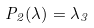<formula> <loc_0><loc_0><loc_500><loc_500>P _ { 2 } ( \lambda ) = \lambda _ { 3 }</formula> 